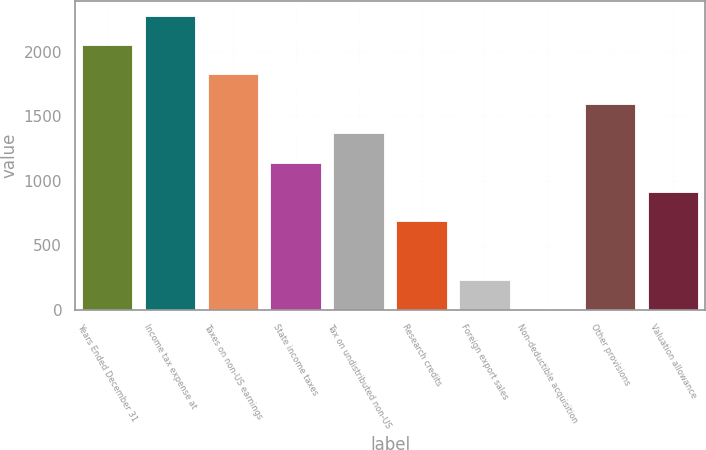Convert chart to OTSL. <chart><loc_0><loc_0><loc_500><loc_500><bar_chart><fcel>Years Ended December 31<fcel>Income tax expense at<fcel>Taxes on non-US earnings<fcel>State income taxes<fcel>Tax on undistributed non-US<fcel>Research credits<fcel>Foreign export sales<fcel>Non-deductible acquisition<fcel>Other provisions<fcel>Valuation allowance<nl><fcel>2054<fcel>2282<fcel>1826<fcel>1142<fcel>1370<fcel>686<fcel>230<fcel>2<fcel>1598<fcel>914<nl></chart> 